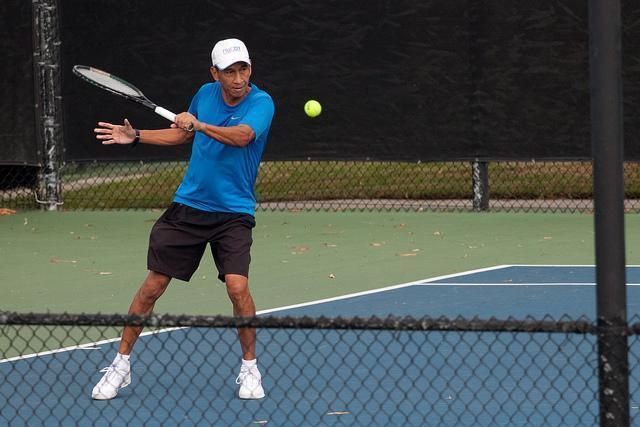What type of shot is this man making?
Select the accurate response from the four choices given to answer the question.
Options: Double, forehand, backhand, none. Backhand. 